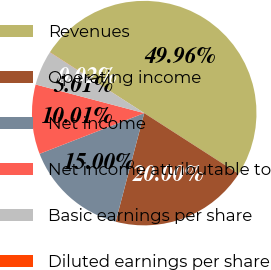Convert chart to OTSL. <chart><loc_0><loc_0><loc_500><loc_500><pie_chart><fcel>Revenues<fcel>Operating income<fcel>Net income<fcel>Net income attributable to<fcel>Basic earnings per share<fcel>Diluted earnings per share<nl><fcel>49.96%<fcel>20.0%<fcel>15.0%<fcel>10.01%<fcel>5.01%<fcel>0.02%<nl></chart> 